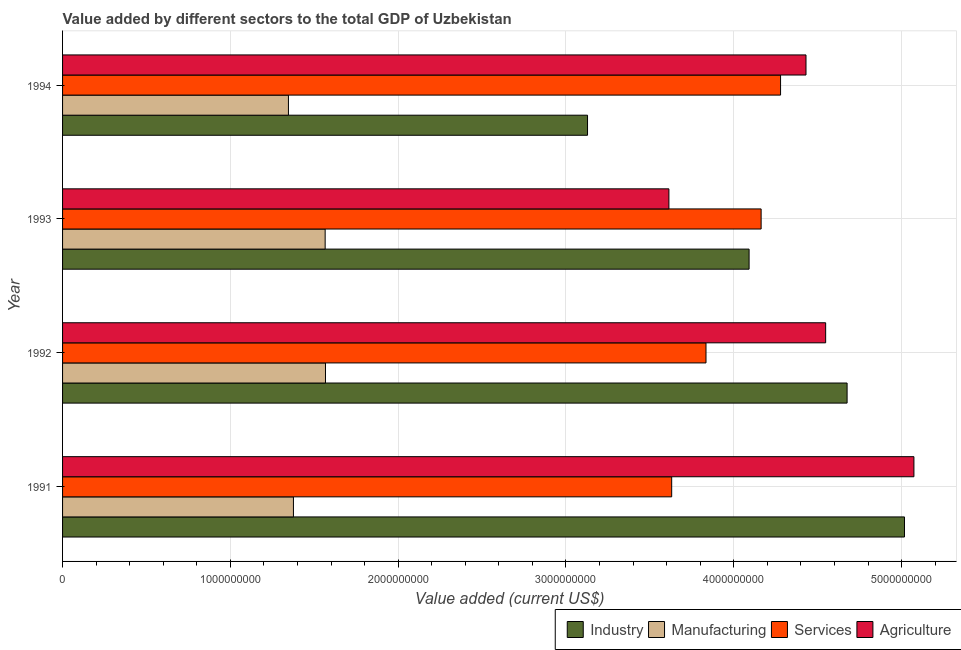How many different coloured bars are there?
Provide a succinct answer. 4. How many groups of bars are there?
Provide a short and direct response. 4. Are the number of bars on each tick of the Y-axis equal?
Your answer should be compact. Yes. How many bars are there on the 4th tick from the bottom?
Your answer should be compact. 4. What is the value added by services sector in 1994?
Your answer should be compact. 4.28e+09. Across all years, what is the maximum value added by services sector?
Make the answer very short. 4.28e+09. Across all years, what is the minimum value added by services sector?
Give a very brief answer. 3.63e+09. In which year was the value added by industrial sector maximum?
Your answer should be compact. 1991. What is the total value added by industrial sector in the graph?
Give a very brief answer. 1.69e+1. What is the difference between the value added by manufacturing sector in 1992 and that in 1994?
Give a very brief answer. 2.21e+08. What is the difference between the value added by services sector in 1993 and the value added by industrial sector in 1992?
Your answer should be compact. -5.12e+08. What is the average value added by industrial sector per year?
Keep it short and to the point. 4.23e+09. In the year 1993, what is the difference between the value added by services sector and value added by manufacturing sector?
Your answer should be compact. 2.60e+09. In how many years, is the value added by industrial sector greater than 3000000000 US$?
Give a very brief answer. 4. What is the ratio of the value added by agricultural sector in 1993 to that in 1994?
Make the answer very short. 0.82. Is the difference between the value added by services sector in 1992 and 1994 greater than the difference between the value added by manufacturing sector in 1992 and 1994?
Your answer should be compact. No. What is the difference between the highest and the second highest value added by manufacturing sector?
Offer a terse response. 2.02e+06. What is the difference between the highest and the lowest value added by manufacturing sector?
Ensure brevity in your answer.  2.21e+08. In how many years, is the value added by services sector greater than the average value added by services sector taken over all years?
Provide a succinct answer. 2. Is the sum of the value added by industrial sector in 1992 and 1993 greater than the maximum value added by services sector across all years?
Your answer should be very brief. Yes. What does the 4th bar from the top in 1994 represents?
Offer a very short reply. Industry. What does the 1st bar from the bottom in 1994 represents?
Your answer should be compact. Industry. Is it the case that in every year, the sum of the value added by industrial sector and value added by manufacturing sector is greater than the value added by services sector?
Provide a short and direct response. Yes. How many years are there in the graph?
Your response must be concise. 4. What is the difference between two consecutive major ticks on the X-axis?
Offer a very short reply. 1.00e+09. Does the graph contain any zero values?
Provide a short and direct response. No. Where does the legend appear in the graph?
Provide a succinct answer. Bottom right. How many legend labels are there?
Give a very brief answer. 4. How are the legend labels stacked?
Your response must be concise. Horizontal. What is the title of the graph?
Ensure brevity in your answer.  Value added by different sectors to the total GDP of Uzbekistan. Does "Goods and services" appear as one of the legend labels in the graph?
Make the answer very short. No. What is the label or title of the X-axis?
Keep it short and to the point. Value added (current US$). What is the label or title of the Y-axis?
Your answer should be compact. Year. What is the Value added (current US$) of Industry in 1991?
Your answer should be very brief. 5.02e+09. What is the Value added (current US$) of Manufacturing in 1991?
Offer a very short reply. 1.38e+09. What is the Value added (current US$) in Services in 1991?
Ensure brevity in your answer.  3.63e+09. What is the Value added (current US$) in Agriculture in 1991?
Give a very brief answer. 5.07e+09. What is the Value added (current US$) in Industry in 1992?
Make the answer very short. 4.68e+09. What is the Value added (current US$) in Manufacturing in 1992?
Ensure brevity in your answer.  1.57e+09. What is the Value added (current US$) of Services in 1992?
Provide a short and direct response. 3.83e+09. What is the Value added (current US$) in Agriculture in 1992?
Your response must be concise. 4.55e+09. What is the Value added (current US$) of Industry in 1993?
Keep it short and to the point. 4.09e+09. What is the Value added (current US$) of Manufacturing in 1993?
Your response must be concise. 1.56e+09. What is the Value added (current US$) of Services in 1993?
Make the answer very short. 4.16e+09. What is the Value added (current US$) of Agriculture in 1993?
Ensure brevity in your answer.  3.61e+09. What is the Value added (current US$) of Industry in 1994?
Your answer should be very brief. 3.13e+09. What is the Value added (current US$) of Manufacturing in 1994?
Make the answer very short. 1.35e+09. What is the Value added (current US$) in Services in 1994?
Give a very brief answer. 4.28e+09. What is the Value added (current US$) of Agriculture in 1994?
Your answer should be compact. 4.43e+09. Across all years, what is the maximum Value added (current US$) in Industry?
Your answer should be very brief. 5.02e+09. Across all years, what is the maximum Value added (current US$) in Manufacturing?
Make the answer very short. 1.57e+09. Across all years, what is the maximum Value added (current US$) in Services?
Offer a terse response. 4.28e+09. Across all years, what is the maximum Value added (current US$) in Agriculture?
Your response must be concise. 5.07e+09. Across all years, what is the minimum Value added (current US$) in Industry?
Give a very brief answer. 3.13e+09. Across all years, what is the minimum Value added (current US$) in Manufacturing?
Make the answer very short. 1.35e+09. Across all years, what is the minimum Value added (current US$) in Services?
Offer a terse response. 3.63e+09. Across all years, what is the minimum Value added (current US$) of Agriculture?
Your answer should be compact. 3.61e+09. What is the total Value added (current US$) of Industry in the graph?
Your response must be concise. 1.69e+1. What is the total Value added (current US$) in Manufacturing in the graph?
Your answer should be compact. 5.85e+09. What is the total Value added (current US$) of Services in the graph?
Your response must be concise. 1.59e+1. What is the total Value added (current US$) in Agriculture in the graph?
Your answer should be very brief. 1.77e+1. What is the difference between the Value added (current US$) of Industry in 1991 and that in 1992?
Ensure brevity in your answer.  3.42e+08. What is the difference between the Value added (current US$) in Manufacturing in 1991 and that in 1992?
Offer a terse response. -1.91e+08. What is the difference between the Value added (current US$) in Services in 1991 and that in 1992?
Keep it short and to the point. -2.05e+08. What is the difference between the Value added (current US$) in Agriculture in 1991 and that in 1992?
Your response must be concise. 5.26e+08. What is the difference between the Value added (current US$) in Industry in 1991 and that in 1993?
Offer a very short reply. 9.26e+08. What is the difference between the Value added (current US$) in Manufacturing in 1991 and that in 1993?
Provide a short and direct response. -1.89e+08. What is the difference between the Value added (current US$) of Services in 1991 and that in 1993?
Offer a very short reply. -5.33e+08. What is the difference between the Value added (current US$) in Agriculture in 1991 and that in 1993?
Your answer should be compact. 1.46e+09. What is the difference between the Value added (current US$) in Industry in 1991 and that in 1994?
Keep it short and to the point. 1.89e+09. What is the difference between the Value added (current US$) of Manufacturing in 1991 and that in 1994?
Your response must be concise. 2.97e+07. What is the difference between the Value added (current US$) of Services in 1991 and that in 1994?
Provide a succinct answer. -6.49e+08. What is the difference between the Value added (current US$) of Agriculture in 1991 and that in 1994?
Your answer should be very brief. 6.43e+08. What is the difference between the Value added (current US$) in Industry in 1992 and that in 1993?
Provide a short and direct response. 5.84e+08. What is the difference between the Value added (current US$) of Manufacturing in 1992 and that in 1993?
Keep it short and to the point. 2.02e+06. What is the difference between the Value added (current US$) in Services in 1992 and that in 1993?
Make the answer very short. -3.29e+08. What is the difference between the Value added (current US$) in Agriculture in 1992 and that in 1993?
Offer a very short reply. 9.34e+08. What is the difference between the Value added (current US$) of Industry in 1992 and that in 1994?
Offer a terse response. 1.55e+09. What is the difference between the Value added (current US$) of Manufacturing in 1992 and that in 1994?
Make the answer very short. 2.21e+08. What is the difference between the Value added (current US$) in Services in 1992 and that in 1994?
Keep it short and to the point. -4.44e+08. What is the difference between the Value added (current US$) of Agriculture in 1992 and that in 1994?
Your answer should be very brief. 1.17e+08. What is the difference between the Value added (current US$) of Industry in 1993 and that in 1994?
Make the answer very short. 9.63e+08. What is the difference between the Value added (current US$) of Manufacturing in 1993 and that in 1994?
Offer a very short reply. 2.19e+08. What is the difference between the Value added (current US$) in Services in 1993 and that in 1994?
Your answer should be compact. -1.16e+08. What is the difference between the Value added (current US$) in Agriculture in 1993 and that in 1994?
Your answer should be very brief. -8.17e+08. What is the difference between the Value added (current US$) of Industry in 1991 and the Value added (current US$) of Manufacturing in 1992?
Provide a short and direct response. 3.45e+09. What is the difference between the Value added (current US$) of Industry in 1991 and the Value added (current US$) of Services in 1992?
Keep it short and to the point. 1.18e+09. What is the difference between the Value added (current US$) of Industry in 1991 and the Value added (current US$) of Agriculture in 1992?
Make the answer very short. 4.70e+08. What is the difference between the Value added (current US$) of Manufacturing in 1991 and the Value added (current US$) of Services in 1992?
Provide a succinct answer. -2.46e+09. What is the difference between the Value added (current US$) in Manufacturing in 1991 and the Value added (current US$) in Agriculture in 1992?
Keep it short and to the point. -3.17e+09. What is the difference between the Value added (current US$) of Services in 1991 and the Value added (current US$) of Agriculture in 1992?
Keep it short and to the point. -9.18e+08. What is the difference between the Value added (current US$) in Industry in 1991 and the Value added (current US$) in Manufacturing in 1993?
Your answer should be compact. 3.45e+09. What is the difference between the Value added (current US$) in Industry in 1991 and the Value added (current US$) in Services in 1993?
Offer a terse response. 8.54e+08. What is the difference between the Value added (current US$) in Industry in 1991 and the Value added (current US$) in Agriculture in 1993?
Provide a succinct answer. 1.40e+09. What is the difference between the Value added (current US$) of Manufacturing in 1991 and the Value added (current US$) of Services in 1993?
Your response must be concise. -2.79e+09. What is the difference between the Value added (current US$) in Manufacturing in 1991 and the Value added (current US$) in Agriculture in 1993?
Provide a short and direct response. -2.24e+09. What is the difference between the Value added (current US$) in Services in 1991 and the Value added (current US$) in Agriculture in 1993?
Ensure brevity in your answer.  1.65e+07. What is the difference between the Value added (current US$) of Industry in 1991 and the Value added (current US$) of Manufacturing in 1994?
Provide a short and direct response. 3.67e+09. What is the difference between the Value added (current US$) in Industry in 1991 and the Value added (current US$) in Services in 1994?
Provide a succinct answer. 7.39e+08. What is the difference between the Value added (current US$) in Industry in 1991 and the Value added (current US$) in Agriculture in 1994?
Ensure brevity in your answer.  5.87e+08. What is the difference between the Value added (current US$) in Manufacturing in 1991 and the Value added (current US$) in Services in 1994?
Keep it short and to the point. -2.90e+09. What is the difference between the Value added (current US$) in Manufacturing in 1991 and the Value added (current US$) in Agriculture in 1994?
Keep it short and to the point. -3.05e+09. What is the difference between the Value added (current US$) in Services in 1991 and the Value added (current US$) in Agriculture in 1994?
Ensure brevity in your answer.  -8.00e+08. What is the difference between the Value added (current US$) in Industry in 1992 and the Value added (current US$) in Manufacturing in 1993?
Make the answer very short. 3.11e+09. What is the difference between the Value added (current US$) in Industry in 1992 and the Value added (current US$) in Services in 1993?
Make the answer very short. 5.12e+08. What is the difference between the Value added (current US$) in Industry in 1992 and the Value added (current US$) in Agriculture in 1993?
Give a very brief answer. 1.06e+09. What is the difference between the Value added (current US$) in Manufacturing in 1992 and the Value added (current US$) in Services in 1993?
Offer a very short reply. -2.60e+09. What is the difference between the Value added (current US$) in Manufacturing in 1992 and the Value added (current US$) in Agriculture in 1993?
Give a very brief answer. -2.05e+09. What is the difference between the Value added (current US$) of Services in 1992 and the Value added (current US$) of Agriculture in 1993?
Offer a terse response. 2.21e+08. What is the difference between the Value added (current US$) of Industry in 1992 and the Value added (current US$) of Manufacturing in 1994?
Provide a short and direct response. 3.33e+09. What is the difference between the Value added (current US$) of Industry in 1992 and the Value added (current US$) of Services in 1994?
Your response must be concise. 3.97e+08. What is the difference between the Value added (current US$) of Industry in 1992 and the Value added (current US$) of Agriculture in 1994?
Keep it short and to the point. 2.45e+08. What is the difference between the Value added (current US$) of Manufacturing in 1992 and the Value added (current US$) of Services in 1994?
Offer a very short reply. -2.71e+09. What is the difference between the Value added (current US$) of Manufacturing in 1992 and the Value added (current US$) of Agriculture in 1994?
Provide a short and direct response. -2.86e+09. What is the difference between the Value added (current US$) in Services in 1992 and the Value added (current US$) in Agriculture in 1994?
Your response must be concise. -5.96e+08. What is the difference between the Value added (current US$) of Industry in 1993 and the Value added (current US$) of Manufacturing in 1994?
Provide a short and direct response. 2.75e+09. What is the difference between the Value added (current US$) of Industry in 1993 and the Value added (current US$) of Services in 1994?
Make the answer very short. -1.88e+08. What is the difference between the Value added (current US$) in Industry in 1993 and the Value added (current US$) in Agriculture in 1994?
Give a very brief answer. -3.39e+08. What is the difference between the Value added (current US$) of Manufacturing in 1993 and the Value added (current US$) of Services in 1994?
Keep it short and to the point. -2.71e+09. What is the difference between the Value added (current US$) of Manufacturing in 1993 and the Value added (current US$) of Agriculture in 1994?
Provide a short and direct response. -2.87e+09. What is the difference between the Value added (current US$) of Services in 1993 and the Value added (current US$) of Agriculture in 1994?
Offer a very short reply. -2.67e+08. What is the average Value added (current US$) of Industry per year?
Provide a succinct answer. 4.23e+09. What is the average Value added (current US$) of Manufacturing per year?
Provide a succinct answer. 1.46e+09. What is the average Value added (current US$) of Services per year?
Keep it short and to the point. 3.98e+09. What is the average Value added (current US$) in Agriculture per year?
Your response must be concise. 4.42e+09. In the year 1991, what is the difference between the Value added (current US$) in Industry and Value added (current US$) in Manufacturing?
Your answer should be very brief. 3.64e+09. In the year 1991, what is the difference between the Value added (current US$) of Industry and Value added (current US$) of Services?
Your answer should be compact. 1.39e+09. In the year 1991, what is the difference between the Value added (current US$) of Industry and Value added (current US$) of Agriculture?
Offer a terse response. -5.62e+07. In the year 1991, what is the difference between the Value added (current US$) in Manufacturing and Value added (current US$) in Services?
Ensure brevity in your answer.  -2.25e+09. In the year 1991, what is the difference between the Value added (current US$) in Manufacturing and Value added (current US$) in Agriculture?
Make the answer very short. -3.70e+09. In the year 1991, what is the difference between the Value added (current US$) in Services and Value added (current US$) in Agriculture?
Your response must be concise. -1.44e+09. In the year 1992, what is the difference between the Value added (current US$) of Industry and Value added (current US$) of Manufacturing?
Your response must be concise. 3.11e+09. In the year 1992, what is the difference between the Value added (current US$) of Industry and Value added (current US$) of Services?
Ensure brevity in your answer.  8.41e+08. In the year 1992, what is the difference between the Value added (current US$) in Industry and Value added (current US$) in Agriculture?
Provide a short and direct response. 1.28e+08. In the year 1992, what is the difference between the Value added (current US$) of Manufacturing and Value added (current US$) of Services?
Your answer should be very brief. -2.27e+09. In the year 1992, what is the difference between the Value added (current US$) of Manufacturing and Value added (current US$) of Agriculture?
Provide a short and direct response. -2.98e+09. In the year 1992, what is the difference between the Value added (current US$) of Services and Value added (current US$) of Agriculture?
Your answer should be very brief. -7.13e+08. In the year 1993, what is the difference between the Value added (current US$) of Industry and Value added (current US$) of Manufacturing?
Your response must be concise. 2.53e+09. In the year 1993, what is the difference between the Value added (current US$) of Industry and Value added (current US$) of Services?
Offer a very short reply. -7.17e+07. In the year 1993, what is the difference between the Value added (current US$) in Industry and Value added (current US$) in Agriculture?
Make the answer very short. 4.78e+08. In the year 1993, what is the difference between the Value added (current US$) in Manufacturing and Value added (current US$) in Services?
Your response must be concise. -2.60e+09. In the year 1993, what is the difference between the Value added (current US$) in Manufacturing and Value added (current US$) in Agriculture?
Ensure brevity in your answer.  -2.05e+09. In the year 1993, what is the difference between the Value added (current US$) in Services and Value added (current US$) in Agriculture?
Provide a succinct answer. 5.50e+08. In the year 1994, what is the difference between the Value added (current US$) in Industry and Value added (current US$) in Manufacturing?
Your answer should be compact. 1.78e+09. In the year 1994, what is the difference between the Value added (current US$) of Industry and Value added (current US$) of Services?
Your answer should be compact. -1.15e+09. In the year 1994, what is the difference between the Value added (current US$) of Industry and Value added (current US$) of Agriculture?
Offer a terse response. -1.30e+09. In the year 1994, what is the difference between the Value added (current US$) in Manufacturing and Value added (current US$) in Services?
Your answer should be very brief. -2.93e+09. In the year 1994, what is the difference between the Value added (current US$) of Manufacturing and Value added (current US$) of Agriculture?
Give a very brief answer. -3.08e+09. In the year 1994, what is the difference between the Value added (current US$) in Services and Value added (current US$) in Agriculture?
Provide a short and direct response. -1.52e+08. What is the ratio of the Value added (current US$) in Industry in 1991 to that in 1992?
Make the answer very short. 1.07. What is the ratio of the Value added (current US$) of Manufacturing in 1991 to that in 1992?
Make the answer very short. 0.88. What is the ratio of the Value added (current US$) in Services in 1991 to that in 1992?
Provide a short and direct response. 0.95. What is the ratio of the Value added (current US$) of Agriculture in 1991 to that in 1992?
Offer a very short reply. 1.12. What is the ratio of the Value added (current US$) in Industry in 1991 to that in 1993?
Keep it short and to the point. 1.23. What is the ratio of the Value added (current US$) in Manufacturing in 1991 to that in 1993?
Offer a terse response. 0.88. What is the ratio of the Value added (current US$) in Services in 1991 to that in 1993?
Make the answer very short. 0.87. What is the ratio of the Value added (current US$) of Agriculture in 1991 to that in 1993?
Your answer should be very brief. 1.4. What is the ratio of the Value added (current US$) of Industry in 1991 to that in 1994?
Offer a very short reply. 1.6. What is the ratio of the Value added (current US$) in Manufacturing in 1991 to that in 1994?
Give a very brief answer. 1.02. What is the ratio of the Value added (current US$) of Services in 1991 to that in 1994?
Ensure brevity in your answer.  0.85. What is the ratio of the Value added (current US$) of Agriculture in 1991 to that in 1994?
Provide a short and direct response. 1.15. What is the ratio of the Value added (current US$) in Industry in 1992 to that in 1993?
Offer a very short reply. 1.14. What is the ratio of the Value added (current US$) of Services in 1992 to that in 1993?
Provide a succinct answer. 0.92. What is the ratio of the Value added (current US$) in Agriculture in 1992 to that in 1993?
Keep it short and to the point. 1.26. What is the ratio of the Value added (current US$) in Industry in 1992 to that in 1994?
Provide a short and direct response. 1.49. What is the ratio of the Value added (current US$) in Manufacturing in 1992 to that in 1994?
Provide a succinct answer. 1.16. What is the ratio of the Value added (current US$) of Services in 1992 to that in 1994?
Offer a very short reply. 0.9. What is the ratio of the Value added (current US$) of Agriculture in 1992 to that in 1994?
Ensure brevity in your answer.  1.03. What is the ratio of the Value added (current US$) in Industry in 1993 to that in 1994?
Offer a terse response. 1.31. What is the ratio of the Value added (current US$) of Manufacturing in 1993 to that in 1994?
Offer a terse response. 1.16. What is the ratio of the Value added (current US$) of Services in 1993 to that in 1994?
Provide a succinct answer. 0.97. What is the ratio of the Value added (current US$) of Agriculture in 1993 to that in 1994?
Make the answer very short. 0.82. What is the difference between the highest and the second highest Value added (current US$) of Industry?
Your answer should be compact. 3.42e+08. What is the difference between the highest and the second highest Value added (current US$) in Manufacturing?
Your answer should be very brief. 2.02e+06. What is the difference between the highest and the second highest Value added (current US$) of Services?
Your answer should be compact. 1.16e+08. What is the difference between the highest and the second highest Value added (current US$) in Agriculture?
Provide a succinct answer. 5.26e+08. What is the difference between the highest and the lowest Value added (current US$) of Industry?
Provide a short and direct response. 1.89e+09. What is the difference between the highest and the lowest Value added (current US$) in Manufacturing?
Your answer should be compact. 2.21e+08. What is the difference between the highest and the lowest Value added (current US$) in Services?
Offer a terse response. 6.49e+08. What is the difference between the highest and the lowest Value added (current US$) in Agriculture?
Provide a short and direct response. 1.46e+09. 